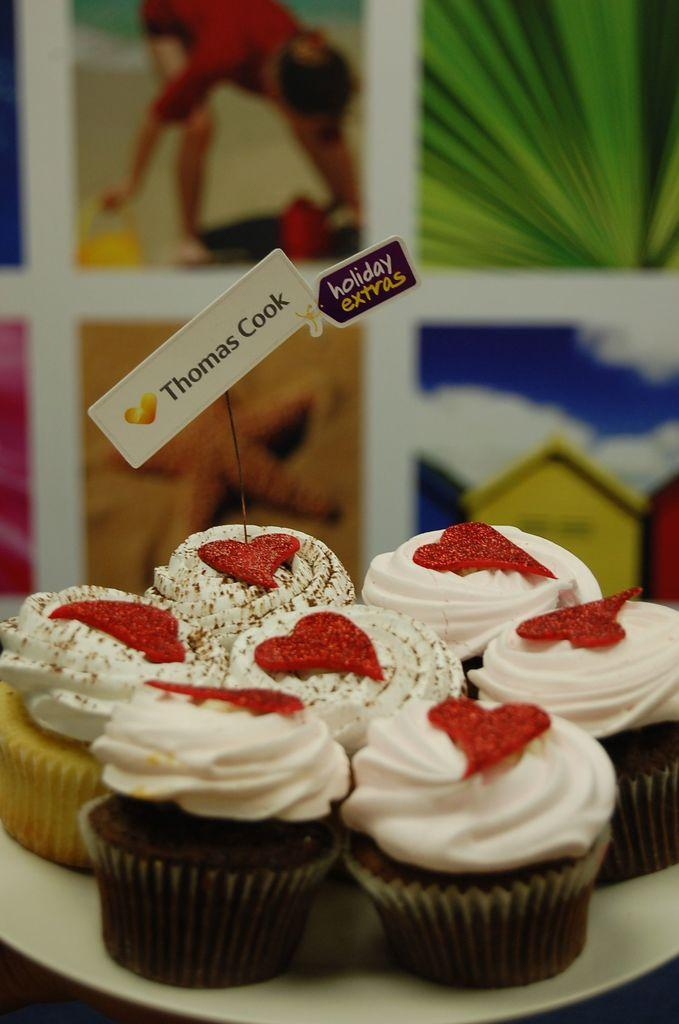What type of food is visible in the image? There are cupcakes in the image. Where are the cupcakes located? The cupcakes are on a plate. What can be seen in the background of the image? There are images in the background of the image. What type of soup is being served in the image? There is no soup present in the image; it features cupcakes on a plate. What type of cushion is visible in the image? There is no cushion present in the image. 